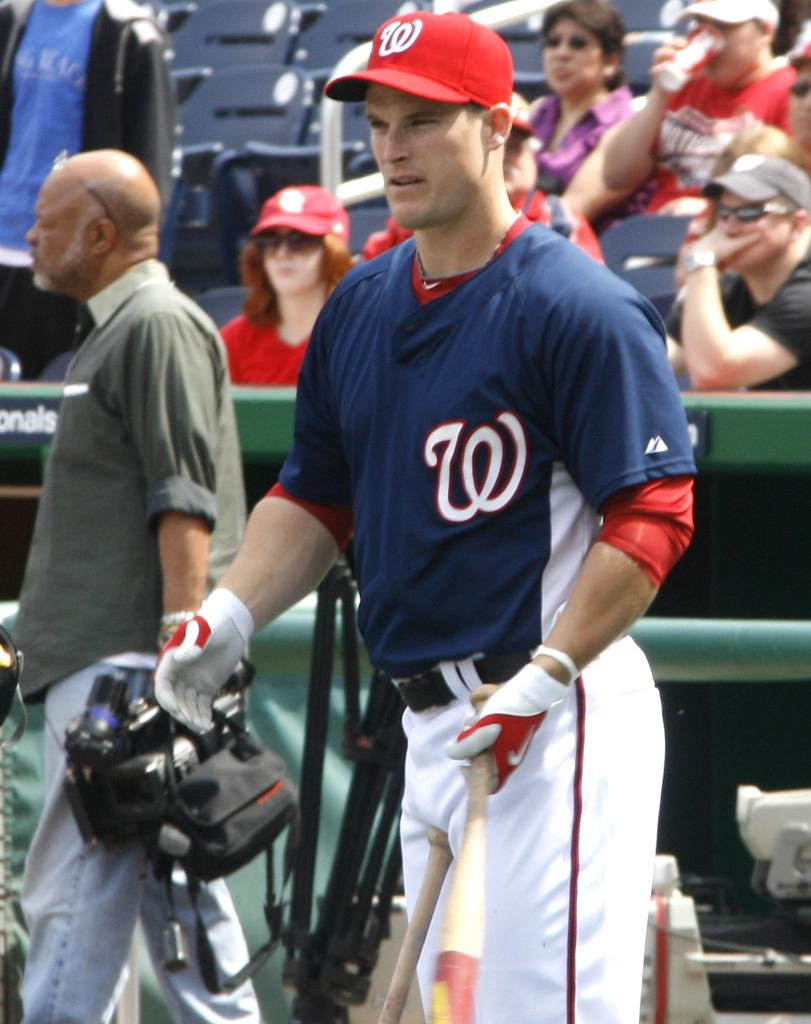How many people are in the image? There are people in the image. What are the two men holding in their hands? Two men are holding objects in their hands. What can be seen in the background of the image? There are chairs in the background of the image. How would you describe the background of the image? The background of the image is blurred. What type of battle is taking place in the image? There is no battle present in the image. What kind of doll is sitting on the chair in the background? There is no doll present in the image. 